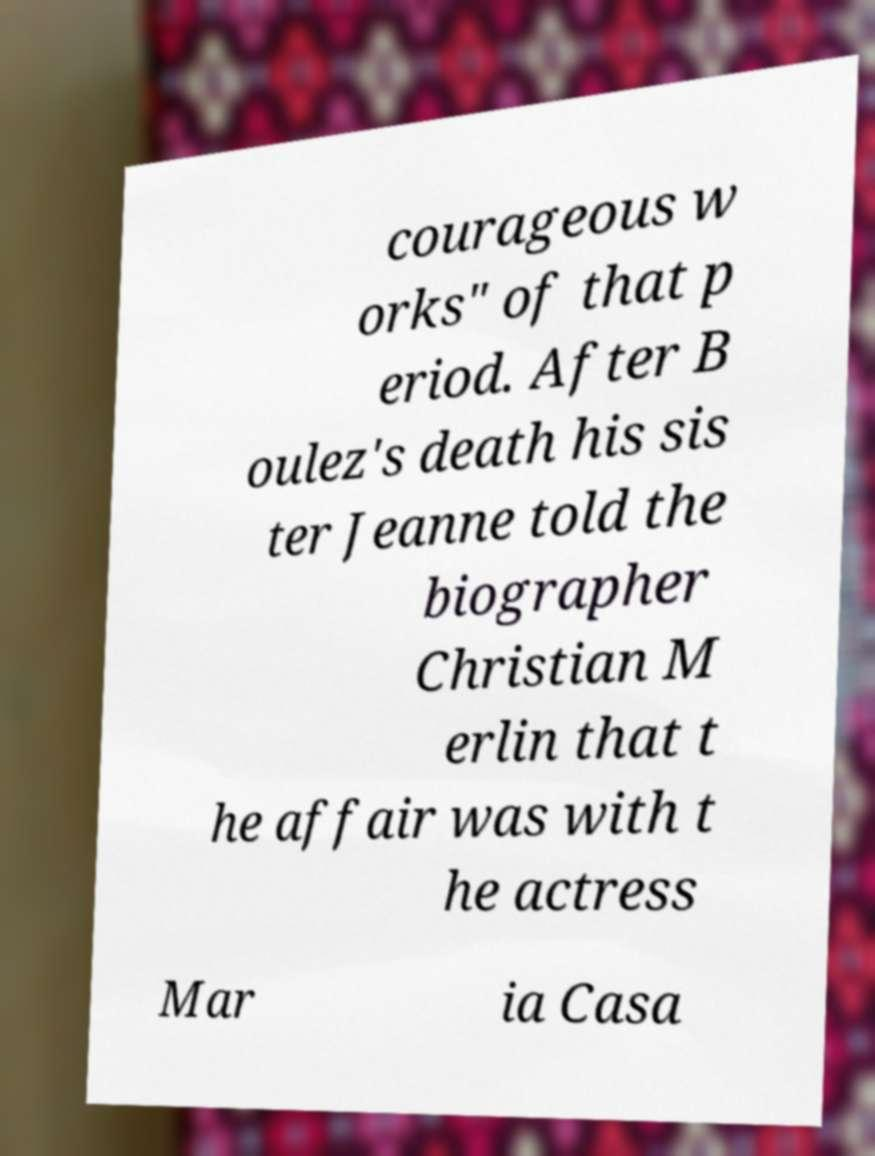Could you extract and type out the text from this image? courageous w orks" of that p eriod. After B oulez's death his sis ter Jeanne told the biographer Christian M erlin that t he affair was with t he actress Mar ia Casa 